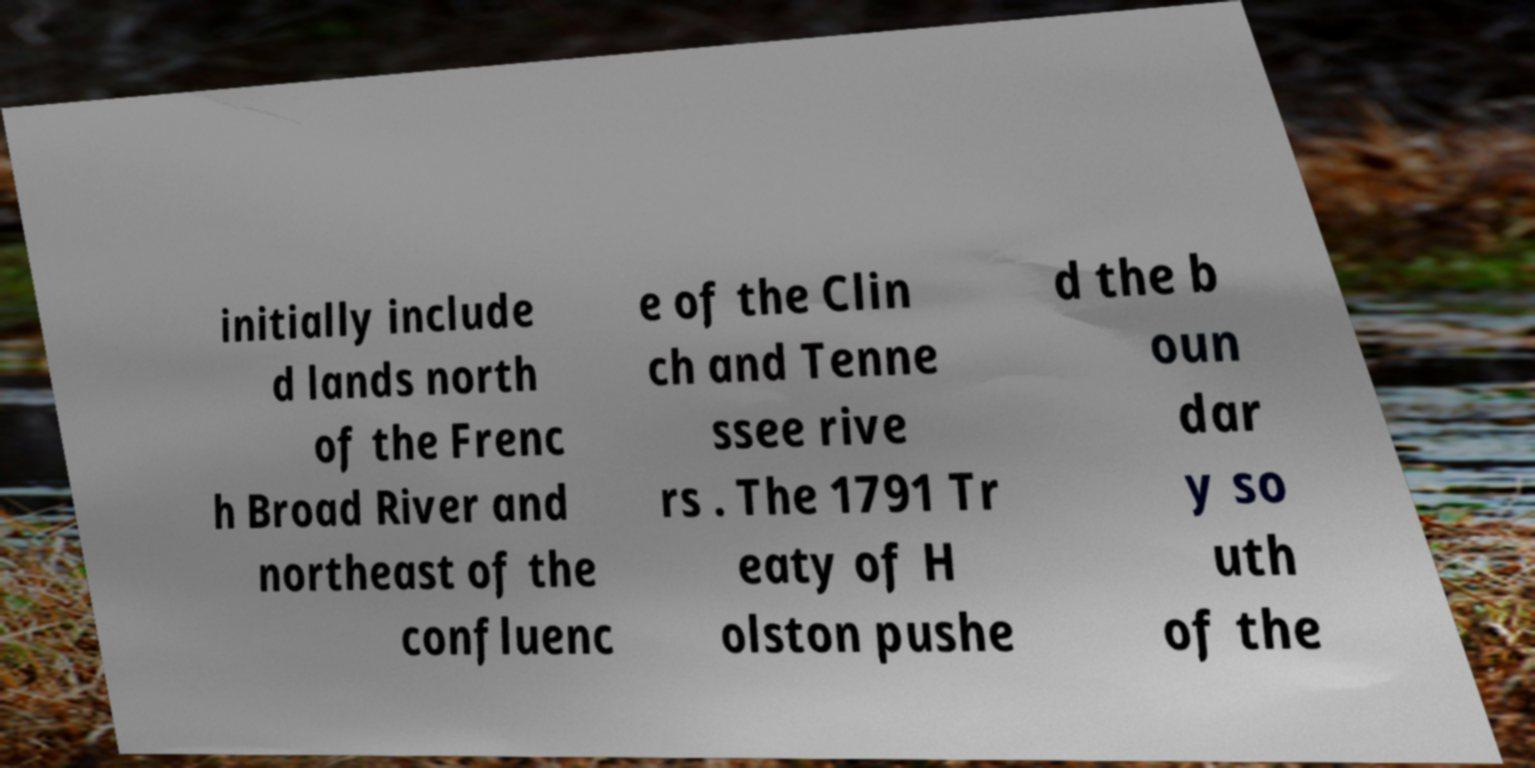I need the written content from this picture converted into text. Can you do that? initially include d lands north of the Frenc h Broad River and northeast of the confluenc e of the Clin ch and Tenne ssee rive rs . The 1791 Tr eaty of H olston pushe d the b oun dar y so uth of the 